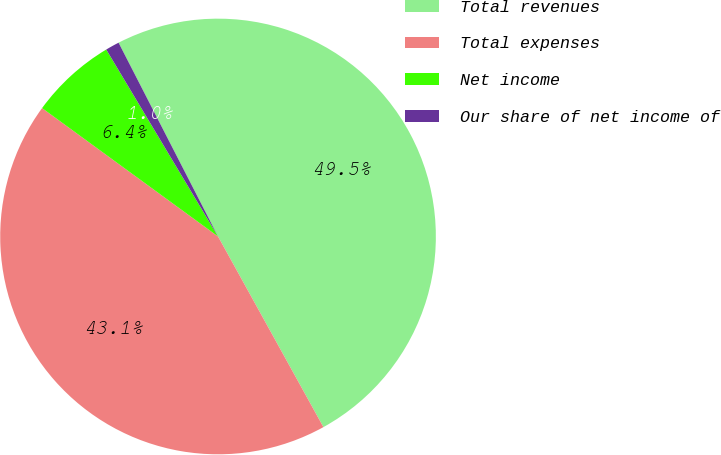<chart> <loc_0><loc_0><loc_500><loc_500><pie_chart><fcel>Total revenues<fcel>Total expenses<fcel>Net income<fcel>Our share of net income of<nl><fcel>49.51%<fcel>43.07%<fcel>6.39%<fcel>1.03%<nl></chart> 